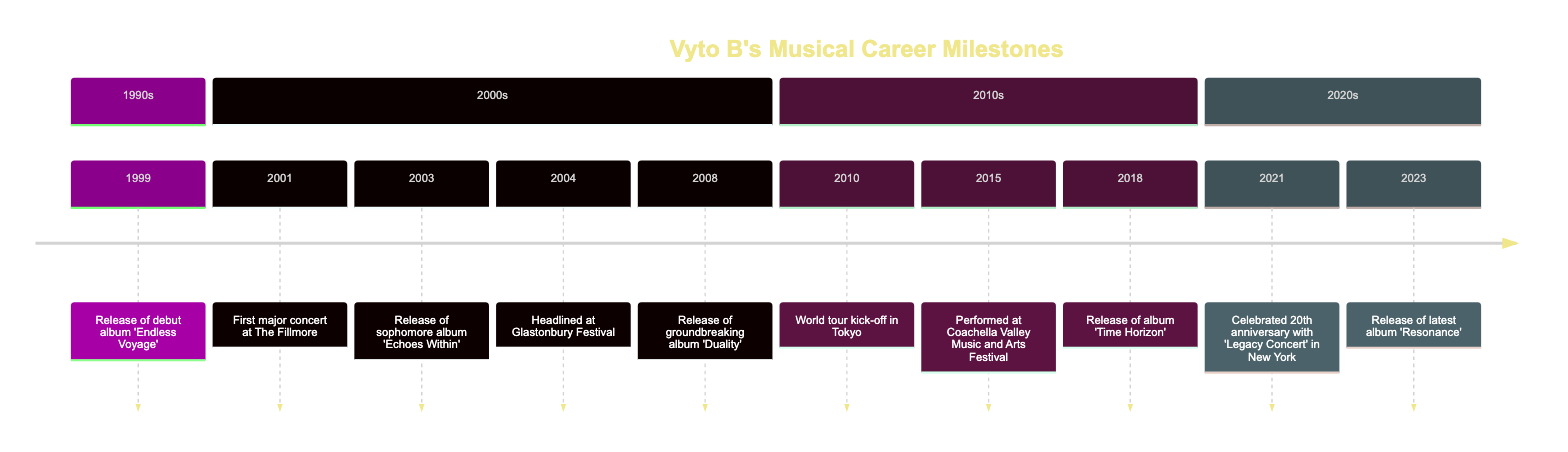What was the title of Vyto B's debut album? The first event listed in the timeline is the release of the debut album, which is stated as 'Endless Voyage'. Thus, the answer is taken directly from this event.
Answer: Endless Voyage When did Vyto B perform at The Fillmore? Looking specifically at the timeline, the event of performing at The Fillmore is marked on the date '2001-08-17'. This shows the date of the performance.
Answer: 2001-08-17 How many albums were released by Vyto B before 2010? Counting the albums listed before the year 2010, there are three albums: 'Endless Voyage', 'Echoes Within', and 'Duality'. Hence, the answer is the count of these albums.
Answer: 3 Which year did Vyto B headline at the Glastonbury Festival? The specific date in the timeline shows that Vyto B headlined at the Glastonbury Festival in '2004-06-15'. This date corresponds specifically to the Glastonbury event.
Answer: 2004 What significant event happened in 2021 for Vyto B? The timeline indicates that in 2021, Vyto B celebrated their 20th anniversary with a 'Legacy Concert' in New York. This event demonstrates the importance of that year.
Answer: Legacy Concert Which album featured the hit single 'Silent Waves'? In the timeline, the second album is stated to be 'Echoes Within', which is also mentioned to showcase the growth of Vyto B and includes the hit single 'Silent Waves'. Therefore, this connects the album with the specific single.
Answer: Echoes Within How many major performances are listed in the timeline? The timeline contains notable concert events as well as album releases. By reviewing the performance milestones, there are four key concert events mentioned: The Fillmore, Glastonbury, Coachella, and the 20th Anniversary concert. Summing these gives the total count of major performances.
Answer: 4 What year did Vyto B release the album 'Resonance'? The timeline explicitly lists 'Resonance' being released on '2023-04-25'. This shows the specific year tied to this album release.
Answer: 2023 Which performance was marked as a pivotal start to a world tour? According to the timeline, the event that marked the start of the world tour is indicated as the performance in Tokyo on '2010-12-10'. This is emphasized in the sequence of timelines.
Answer: World tour kick-off in Tokyo 